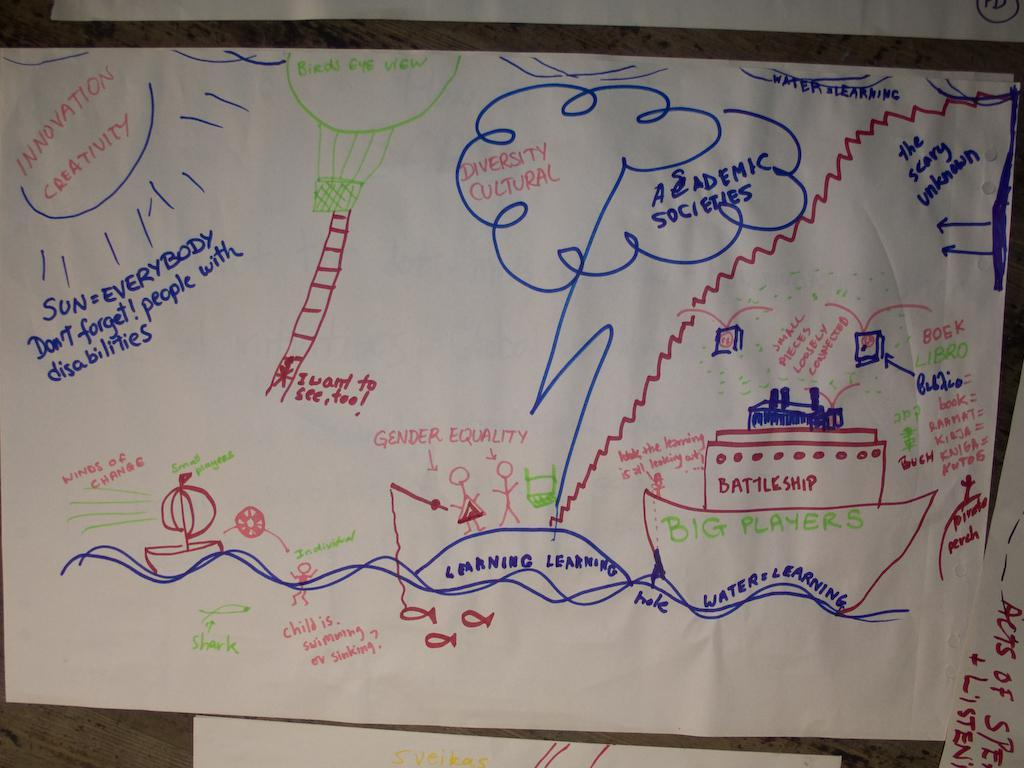<image>
Describe the image concisely. A piece of paper with outlining an Academic Series 